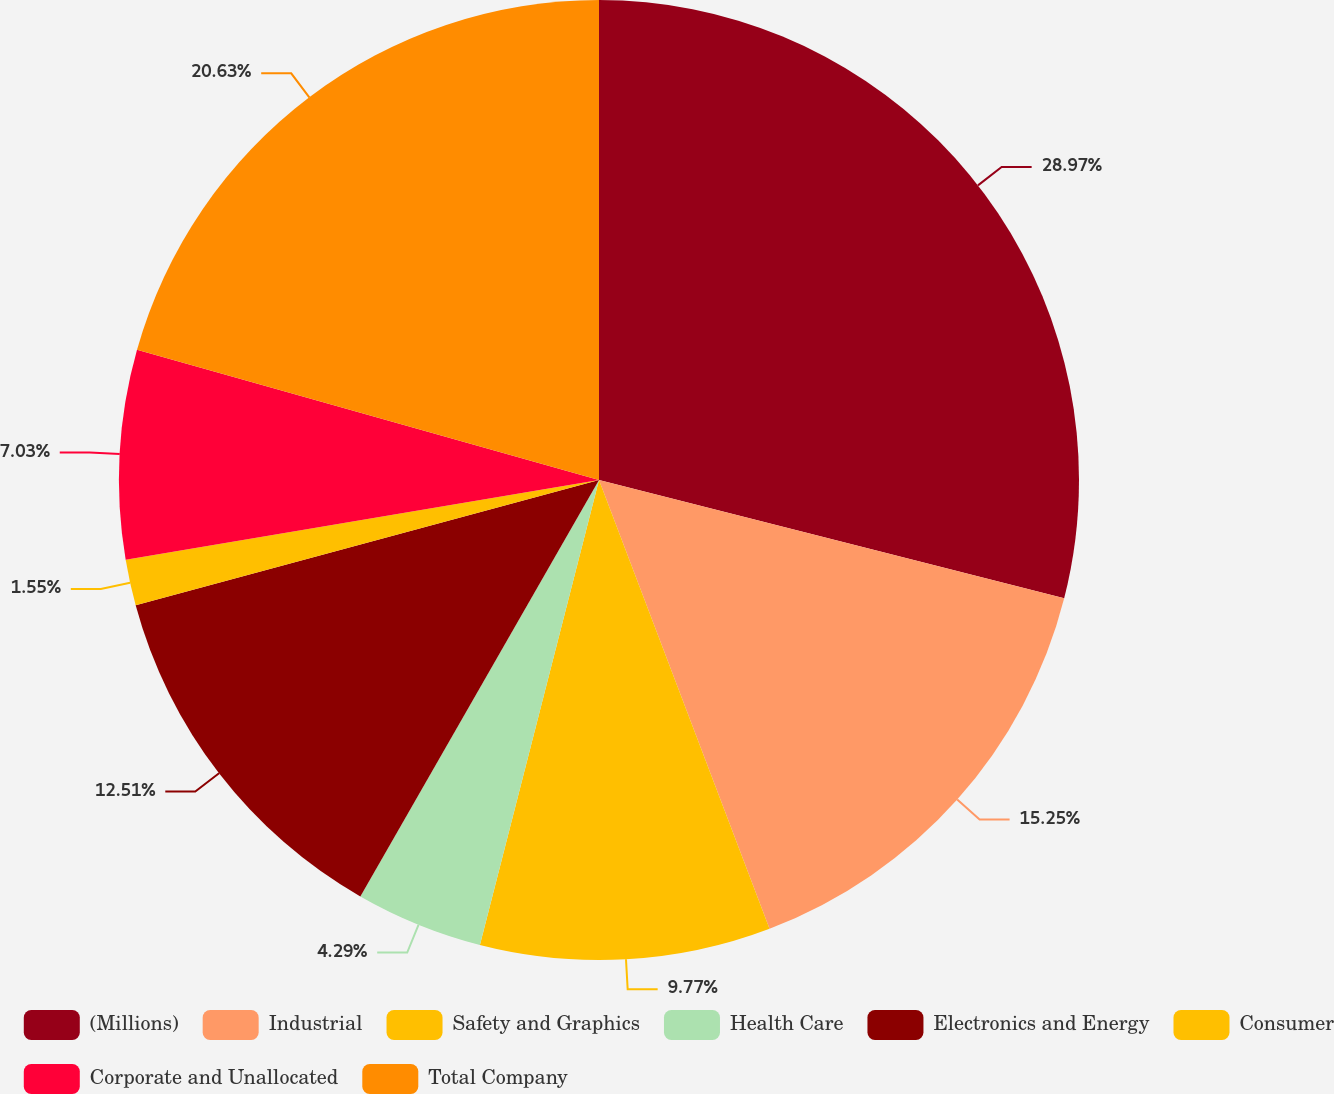Convert chart to OTSL. <chart><loc_0><loc_0><loc_500><loc_500><pie_chart><fcel>(Millions)<fcel>Industrial<fcel>Safety and Graphics<fcel>Health Care<fcel>Electronics and Energy<fcel>Consumer<fcel>Corporate and Unallocated<fcel>Total Company<nl><fcel>28.96%<fcel>15.25%<fcel>9.77%<fcel>4.29%<fcel>12.51%<fcel>1.55%<fcel>7.03%<fcel>20.62%<nl></chart> 